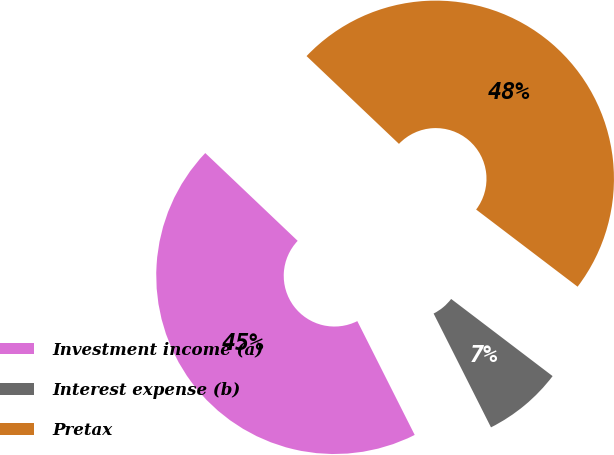Convert chart to OTSL. <chart><loc_0><loc_0><loc_500><loc_500><pie_chart><fcel>Investment income (a)<fcel>Interest expense (b)<fcel>Pretax<nl><fcel>44.53%<fcel>7.22%<fcel>48.26%<nl></chart> 